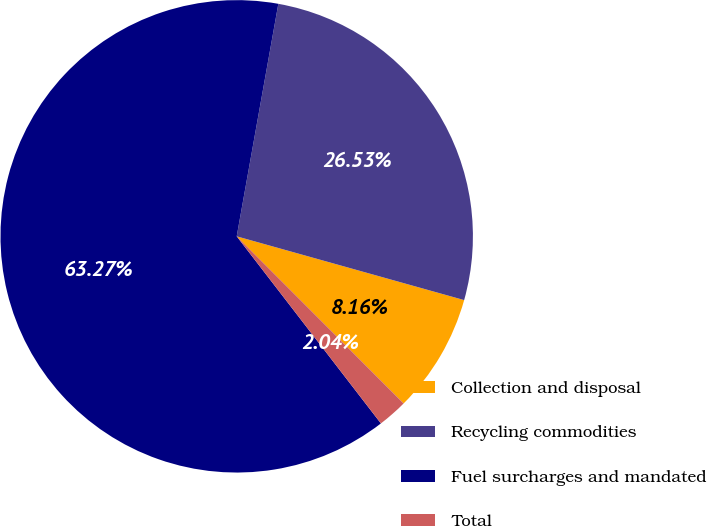Convert chart. <chart><loc_0><loc_0><loc_500><loc_500><pie_chart><fcel>Collection and disposal<fcel>Recycling commodities<fcel>Fuel surcharges and mandated<fcel>Total<nl><fcel>8.16%<fcel>26.53%<fcel>63.27%<fcel>2.04%<nl></chart> 